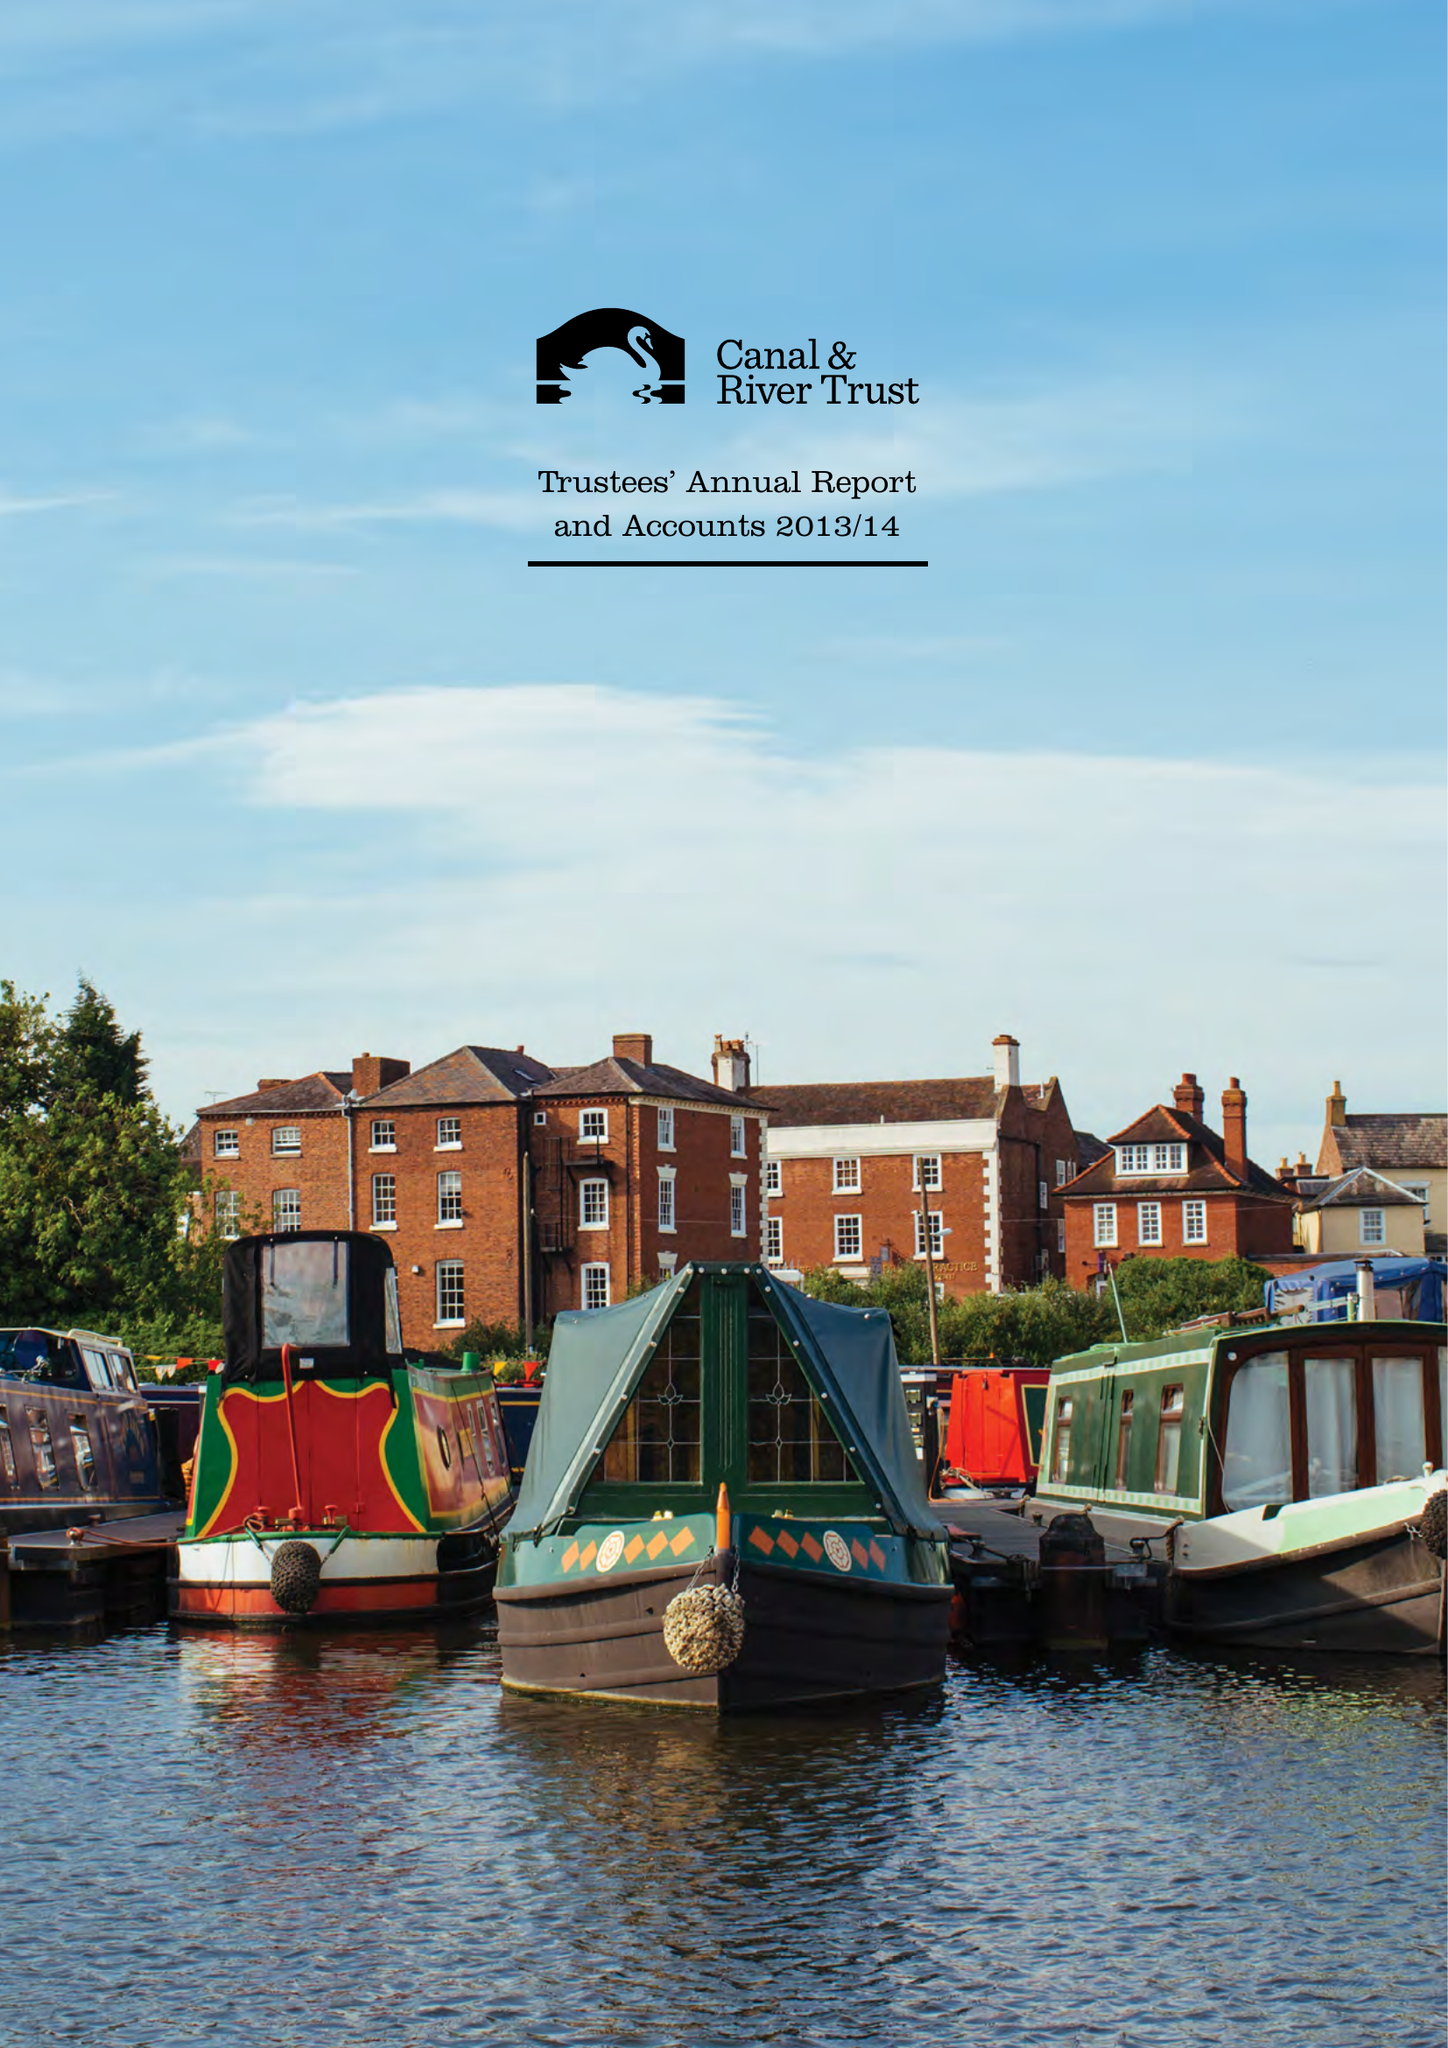What is the value for the income_annually_in_british_pounds?
Answer the question using a single word or phrase. 164600000.00 